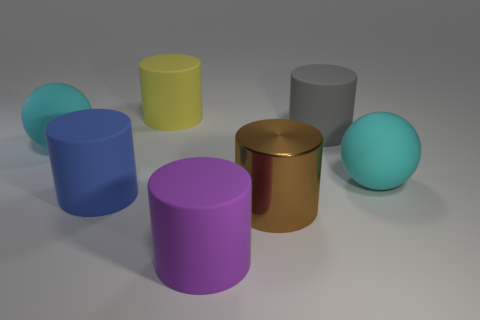How many cyan spheres are made of the same material as the big gray thing?
Offer a terse response. 2. There is a gray object that is the same shape as the blue matte thing; what is its size?
Your answer should be very brief. Large. What is the material of the gray cylinder?
Ensure brevity in your answer.  Rubber. What material is the large cyan object that is to the right of the large sphere left of the big cylinder that is on the left side of the yellow rubber cylinder?
Give a very brief answer. Rubber. Is there anything else that has the same shape as the big brown thing?
Provide a succinct answer. Yes. There is a large metal thing that is the same shape as the gray rubber object; what is its color?
Provide a short and direct response. Brown. There is a large ball to the left of the yellow object; is its color the same as the big ball right of the big blue rubber object?
Ensure brevity in your answer.  Yes. Are there more big purple objects behind the big purple matte object than big brown blocks?
Offer a very short reply. No. How many other things are there of the same size as the metal object?
Keep it short and to the point. 6. What number of objects are both in front of the big blue rubber thing and left of the purple rubber cylinder?
Your answer should be compact. 0. 